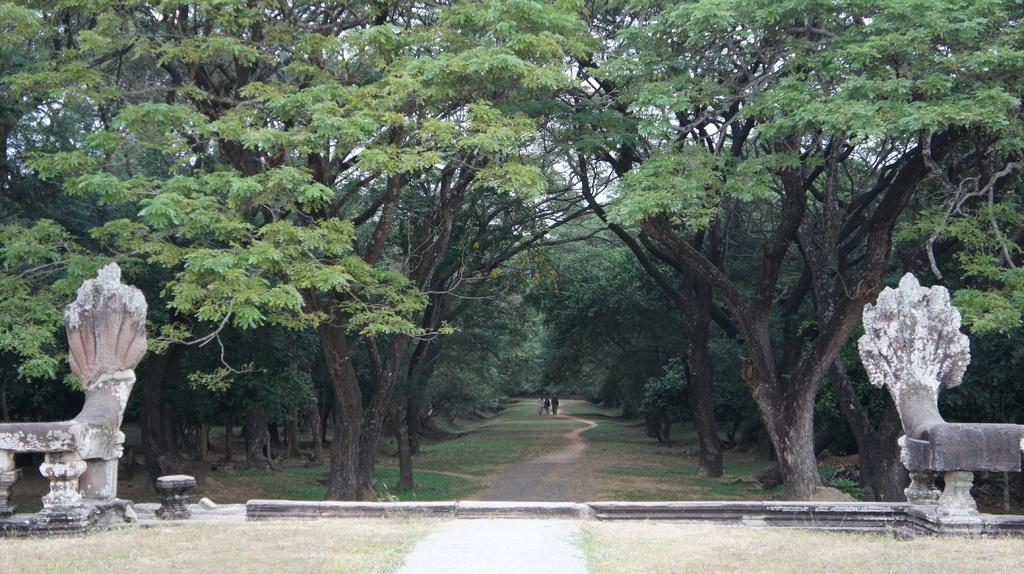Can you describe this image briefly? In this picture we can observe a path. There are two persons walking in this path. There are some trees on either sides of this path. We can observe statues on either sides of the picture. In the background there is a sky. 